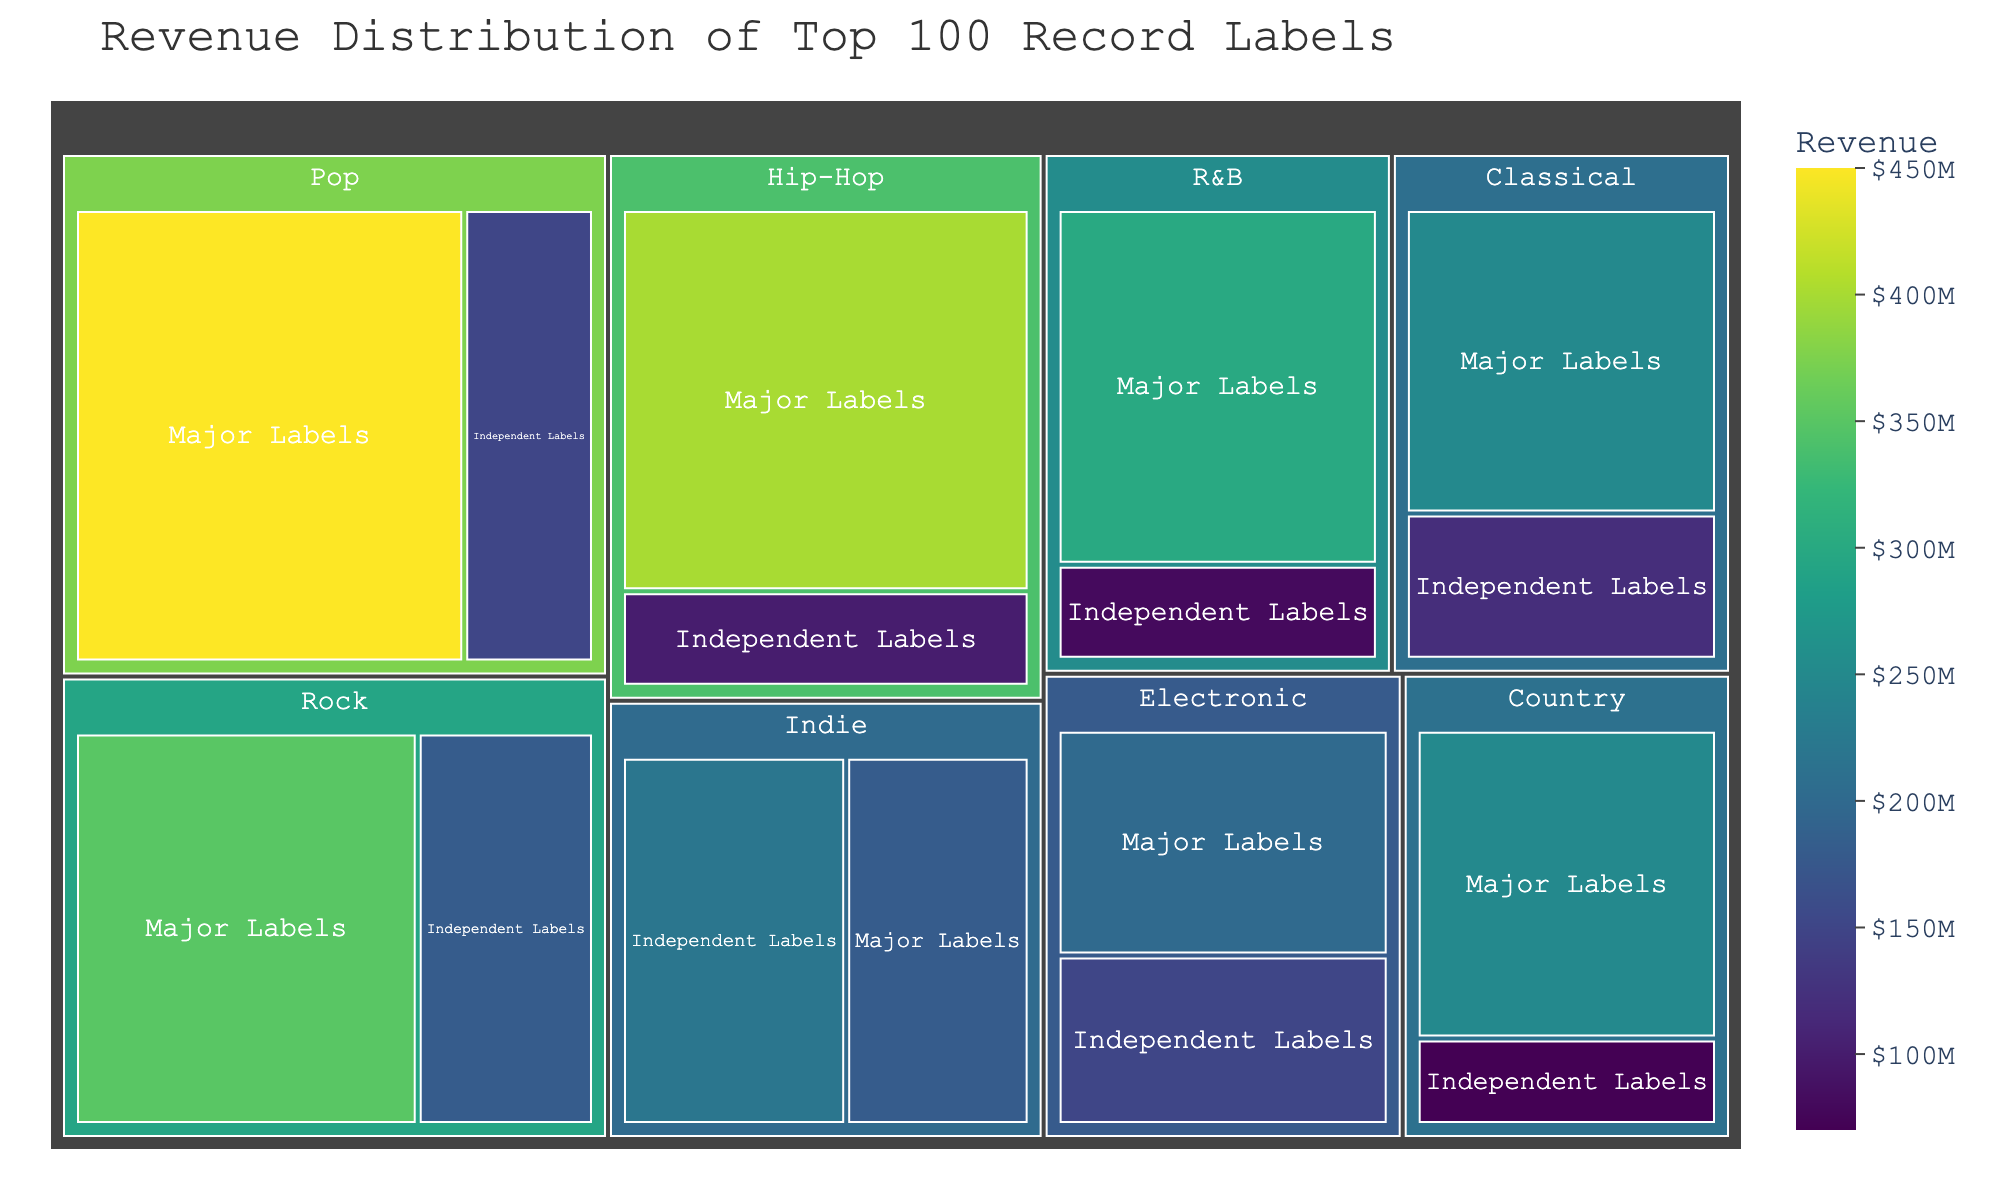What is the title of the figure? The title is usually located at the top center of the figure. In this case, it reads "Revenue Distribution of Top 100 Record Labels".
Answer: Revenue Distribution of Top 100 Record Labels Which music style under major labels generates the most revenue? To find the music style that generates the most revenue under Major Labels, observe the size of the corresponding sections and the actual values. You will see that Pop under Major Labels has the highest value of 450.
Answer: Pop Which category has the lowest revenue among independent labels? To find the least revenue under Independent Labels, look for the smallest section in the Independent Labels category. Country has the smallest section with a value of 70.
Answer: Country How does the revenue from Hip-Hop under Major Labels compare to that from Independent Labels? Compare the values directly. Hip-Hop under Major Labels has a revenue of 400, while Hip-Hop under Independent Labels has a revenue of 100.
Answer: Major Labels generate more revenue If you sum the revenues of Classical and Indie categories under both major and independent labels, which category has higher total revenue? Calculate the total for both categories:
Classical: 250 (Major) + 120 (Independent) = 370
Indie: 180 (Major) + 220 (Independent) = 400. Indie has a higher total revenue.
Answer: Indie What is the combined revenue of Pop and Rock under Major Labels? Add the values for Pop and Rock under Major Labels. Pop: 450, Rock: 350. Thus, 450 + 350 = 800.
Answer: 800 Which category has a more balanced distribution of revenue between Major and Independent Labels: Electronic or R&B? Check the difference in revenues between Major and Independent Labels for both categories.
Electronic: 200 (Major) vs. 150 (Independent), difference = 50
R&B: 300 (Major) vs. 80 (Independent), difference = 220. 
Electronic has a more balanced distribution.
Answer: Electronic What is the average revenue per category under Major Labels? Calculate the total revenue for all categories under Major Labels and divide by the number of categories. 
Categories: Classical (250), Indie (180), Pop (450), Rock (350), Electronic (200), Hip-Hop (400), R&B (300), Country (250)
Total: 250 + 180 + 450 + 350 + 200 + 400 + 300 + 250 = 2380
Average: 2380 / 8 = 297.5
Answer: 297.5 Which music style under Independent Labels generates more revenue, Indie or Rock? Compare the values directly. Indie under Independent Labels has a revenue of 220, while Rock under Independent Labels has a revenue of 180.
Answer: Indie What is the revenue difference between Major Labels and Independent Labels for Country music? Subtract the value of Independent Labels from Major Labels for Country music.
Major: 250, Independent: 70
Difference: 250 - 70 = 180
Answer: 180 